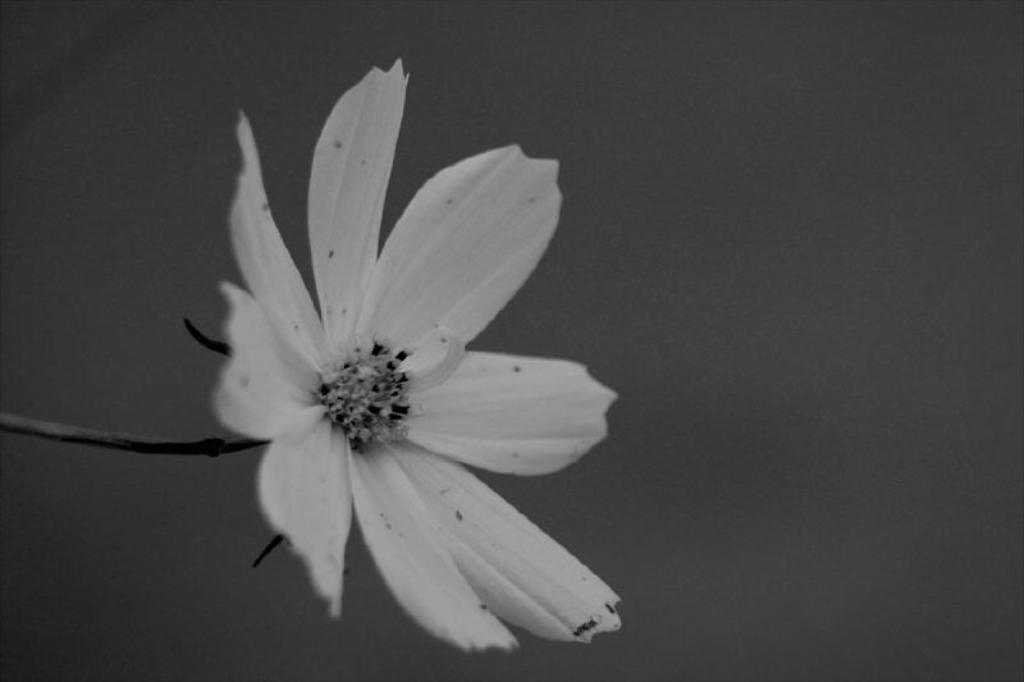What is the color scheme of the image? The image is black and white. What type of plant can be seen in the image? There is a flower in the image. What part of the flower is visible in the image? There is a stem associated with the flower in the image. Can you see any hills in the background of the image? There are no hills visible in the image, as it only features a flower with a stem. What type of match is being used to light the flower in the image? There is no match present in the image, and the flower is not being lit. 